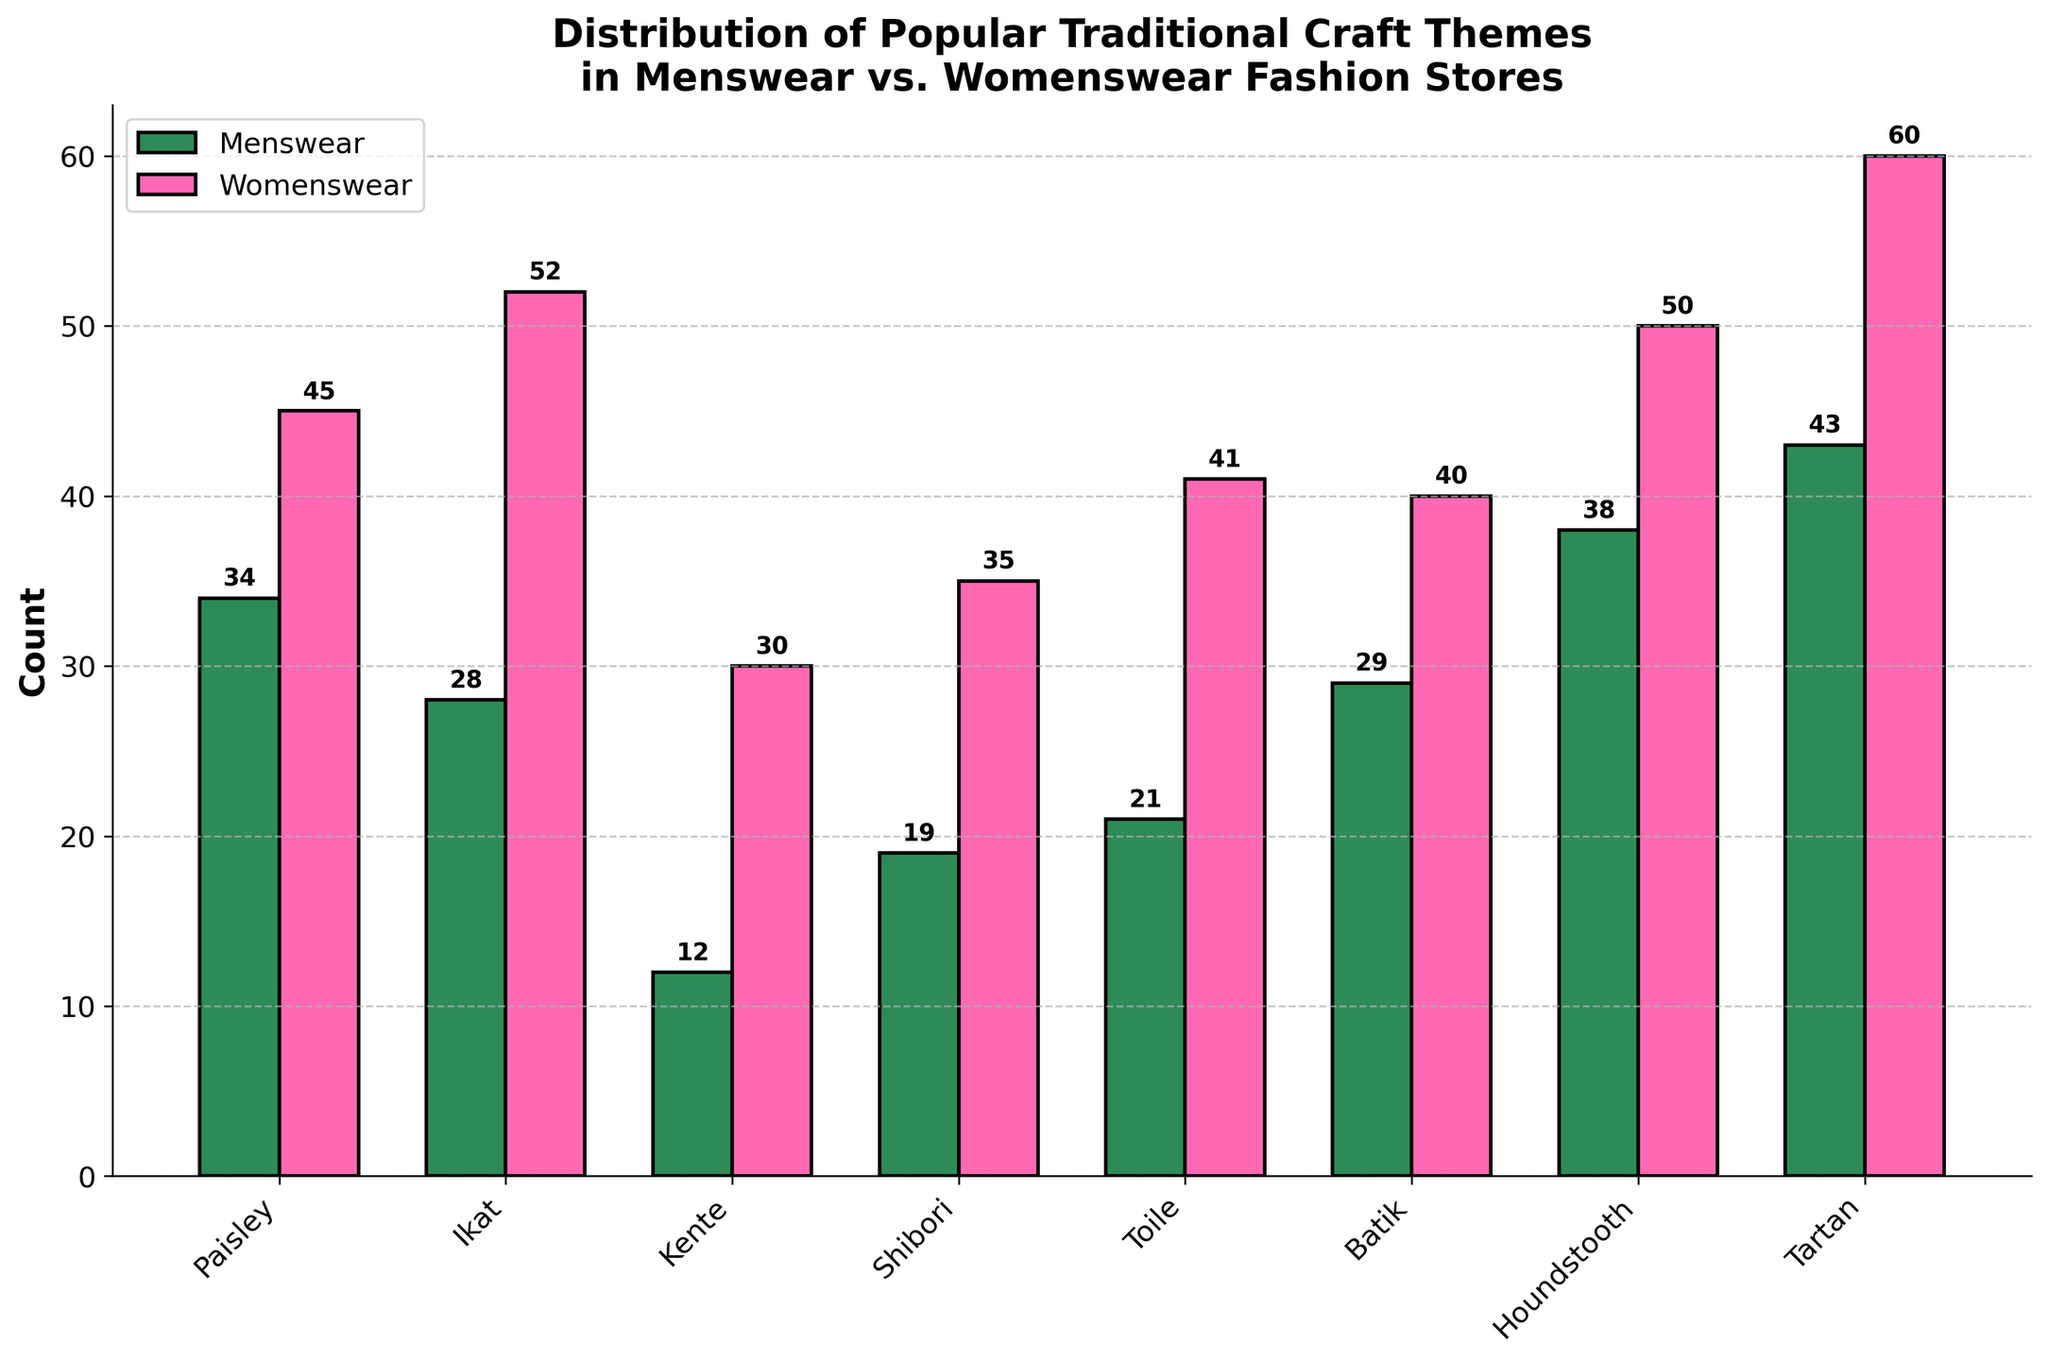Which theme has the highest count in Womenswear? Identify the bar for Womenswear with the highest value, which is the Tartan bar.
Answer: Tartan What's the difference in the count of Shibori between Menswear and Womenswear? Locate the Shibori bars for both Menswear and Womenswear. The counts are 19 and 35, respectively. The difference is 35 - 19 = 16.
Answer: 16 Which gender shows a higher count for the Ikat theme? Compare the height of the bars for Ikat in both Menswear and Womenswear. Womenswear has a higher count of 52 compared to 28 in Menswear.
Answer: Womenswear How many themes have a higher count in Womenswear compared to Menswear? Compare each pair of bars for all themes. The themes with higher counts in Womenswear are Paisley, Ikat, Kente, Shibori, Toile, Batik, Houndstooth, and Tartan. There are 8 such themes.
Answer: 8 What's the total count for Houndstooth theme across both Menswear and Womenswear? Sum the counts for Houndstooth in both genders. The counts are 38 for Menswear and 50 for Womenswear. The total is 38 + 50 = 88.
Answer: 88 What's the average count of themes in Menswear? Add up the counts for all themes in Menswear: 34 + 28 + 12 + 19 + 21 + 29 + 38 + 43 = 224. There are 8 themes, so the average is 224 / 8 = 28.
Answer: 28 Which theme has the smallest difference in counts between Menswear and Womenswear? Calculate the differences for each theme: Paisley (45-34=11), Ikat (52-28=24), Kente (30-12=18), Shibori (35-19=16), Toile (41-21=20), Batik (40-29=11), Houndstooth (50-38=12), Tartan (60-43=17). The smallest difference is for Paisley and Batik, both having a difference of 11.
Answer: Paisley and Batik What is the count for the theme with the lowest value in Menswear? Identify the shortest bar for Menswear, which is Kente with a count of 12.
Answer: 12 